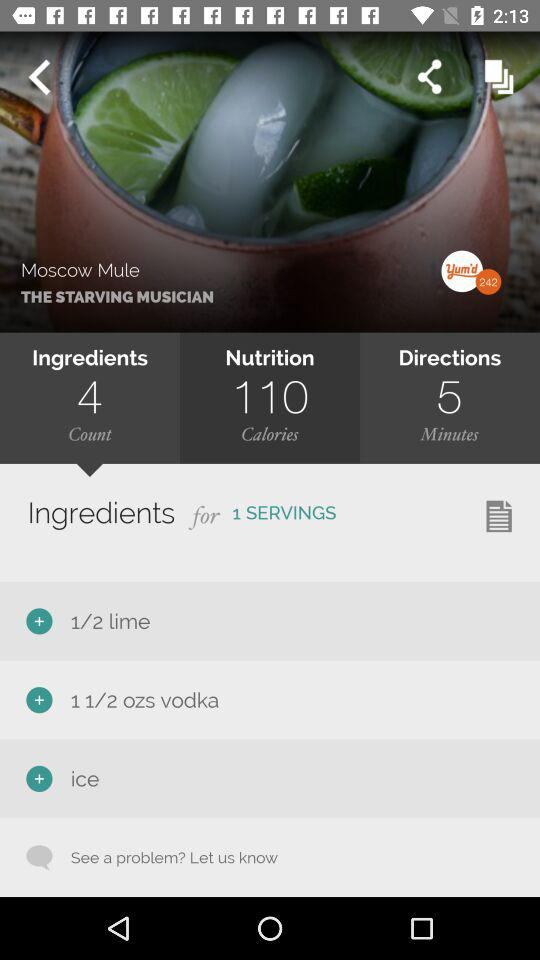What is the count of servings? There is only 1 serving. 